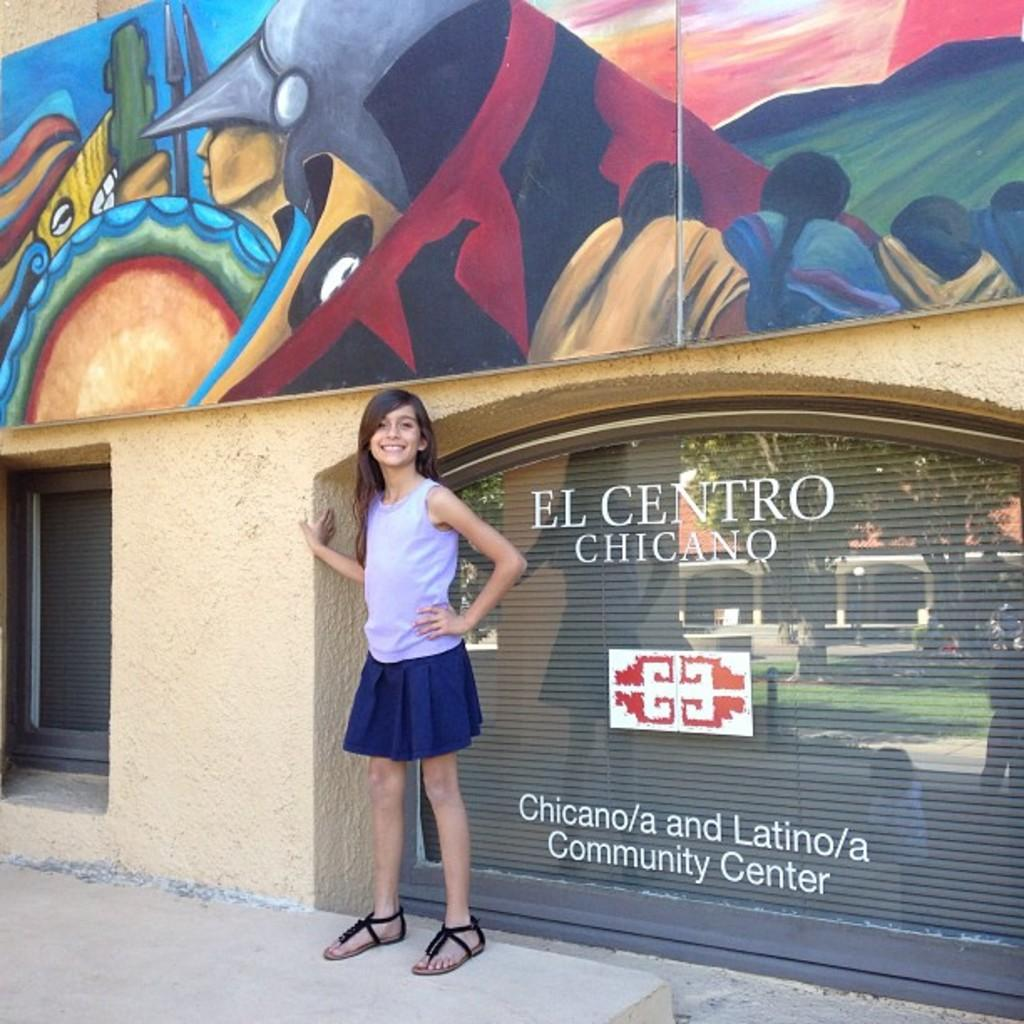Provide a one-sentence caption for the provided image. A girl poses in front of the community center. 